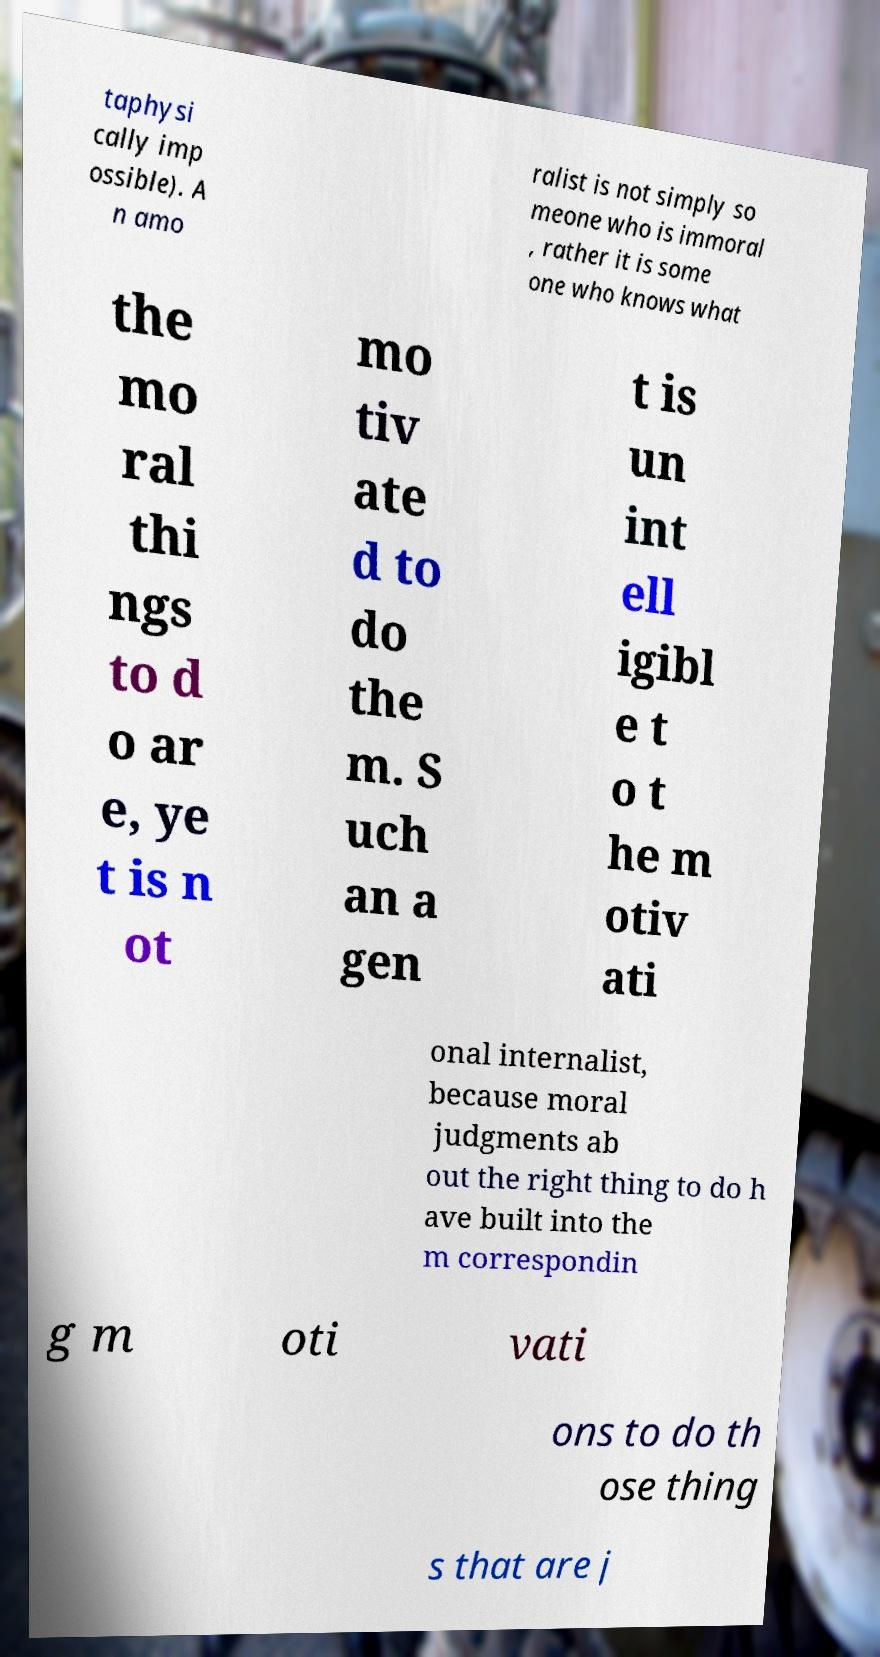There's text embedded in this image that I need extracted. Can you transcribe it verbatim? taphysi cally imp ossible). A n amo ralist is not simply so meone who is immoral , rather it is some one who knows what the mo ral thi ngs to d o ar e, ye t is n ot mo tiv ate d to do the m. S uch an a gen t is un int ell igibl e t o t he m otiv ati onal internalist, because moral judgments ab out the right thing to do h ave built into the m correspondin g m oti vati ons to do th ose thing s that are j 